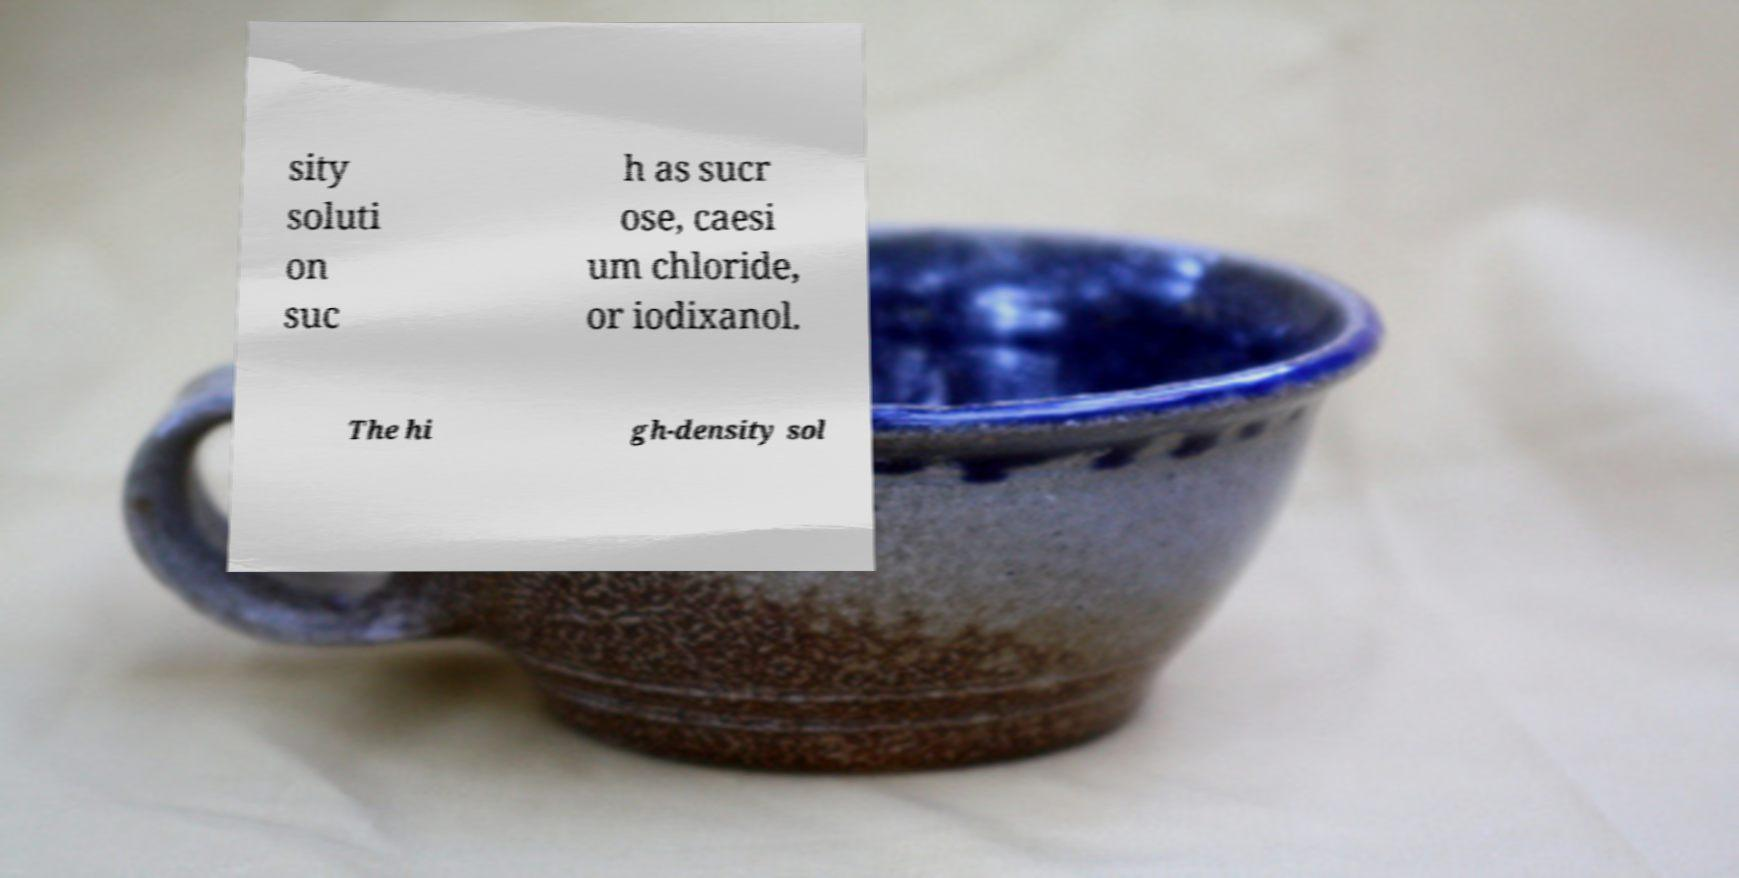Please read and relay the text visible in this image. What does it say? sity soluti on suc h as sucr ose, caesi um chloride, or iodixanol. The hi gh-density sol 